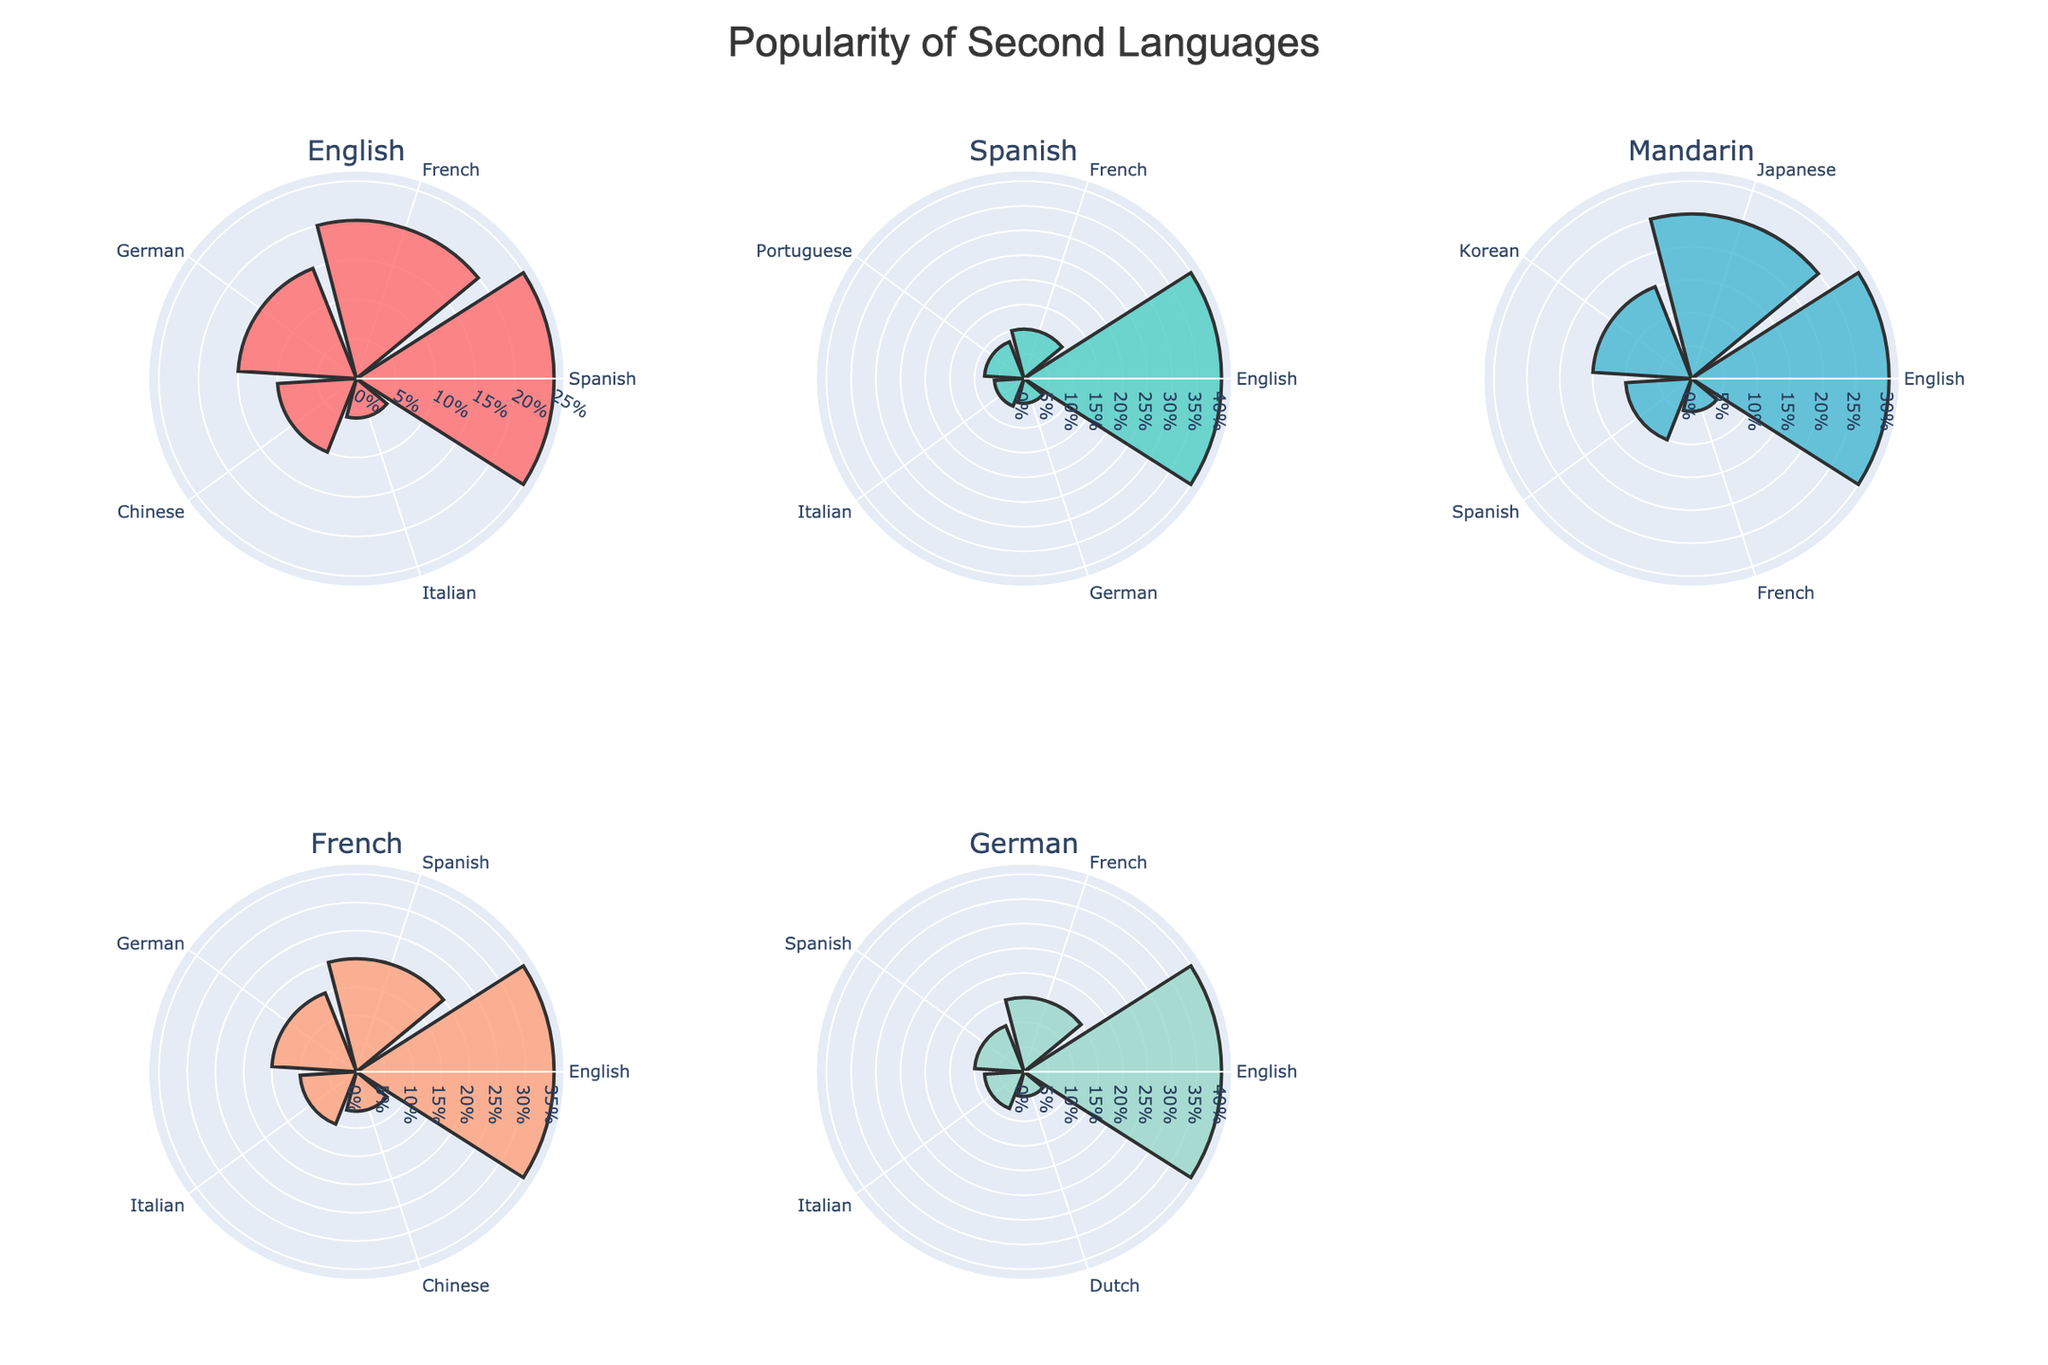What's the title of the figure? The title is usually placed at the top and is meant to give an overview of what the plot is about. In this case, the title is "Popularity of Second Languages."
Answer: Popularity of Second Languages Which language's native speakers study English the most? By looking at the subplot corresponding to each native language, we see that German native speakers have the highest percentage for English as a second language, with 40%.
Answer: German What is the least popular second language among Spanish speakers? In the subplot for Spanish, check the language with the smallest radial value. It is German, with a 5% popularity.
Answer: German Which two second languages have equal popularity among Spanish speakers? In the Spanish subplot, both Portuguese and Italian have similar radial values. Their popularity percentages are 8% and 6% respectively, indicating some similarity.
Answer: Portuguese, Italian Which native language group has the highest percentage for studying a second language? Compare the highest percentages across all subplots. English native speakers study Spanish the most with 25%, Spanish speakers study English the most with 40%, Mandarins study English the most with 30%, French speakers study English the most with 35%, and German speakers study English the most with 40%. Therefore, the highest value is 40%, associated with both Spanish and German native speakers.
Answer: Spanish, German Which second language is studied the most across all native languages? Examine each subplot, identifying which second language has the highest radial value. English is the most popular second language overall, appearing with the highest values in several subplots (40% for German, 40% for Spanish, 35% for French, 30% for Mandarin).
Answer: English What percentage of Mandarin speakers study French? In the Mandarin subplot, look for the radial value next to French. It is 5%.
Answer: 5% Compare the popularity of Spanish as a second language among English speakers and French speakers. Which group has a higher percentage? English speakers have Spanish at 25% and French speakers have Spanish at 20%. Compare these two values.
Answer: English speakers What is the sum of popularity percentages for all second languages studied by French speakers? Add all the values from the French subplot: 35% (English) + 20% (Spanish) + 15% (German) + 10% (Italian) + 7% (Chinese) = 87%.
Answer: 87% Which second language is least popular among both Mandarin and English speakers? Identify the least popular second languages in both the Mandarin and English subplots. For Mandarin, it's French at 5%, and for English, it's Italian at 5%.
Answer: French, Italian 